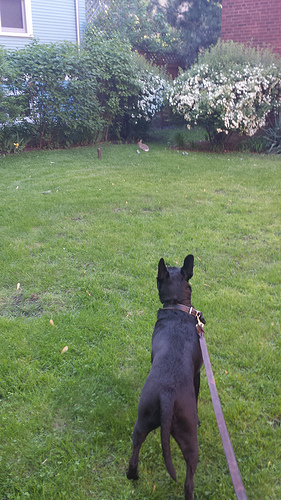<image>
Is the grass on the dog? No. The grass is not positioned on the dog. They may be near each other, but the grass is not supported by or resting on top of the dog. 